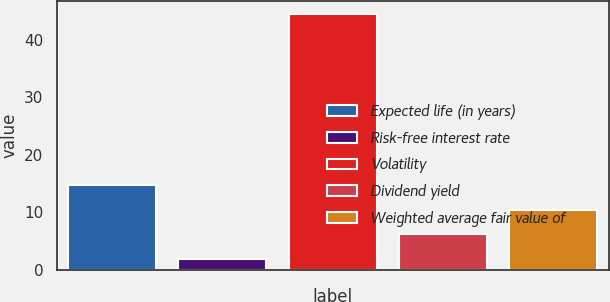Convert chart. <chart><loc_0><loc_0><loc_500><loc_500><bar_chart><fcel>Expected life (in years)<fcel>Risk-free interest rate<fcel>Volatility<fcel>Dividend yield<fcel>Weighted average fair value of<nl><fcel>14.68<fcel>1.87<fcel>44.6<fcel>6.14<fcel>10.41<nl></chart> 